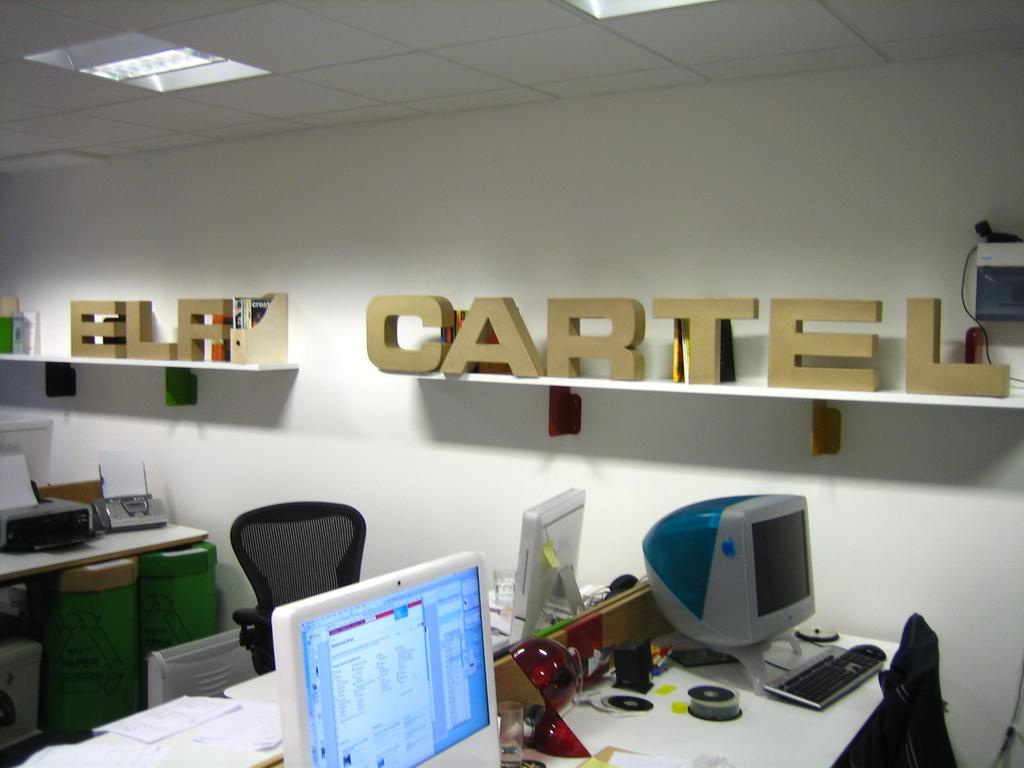<image>
Relay a brief, clear account of the picture shown. A office that has ELF CARTEL on a shelf. 